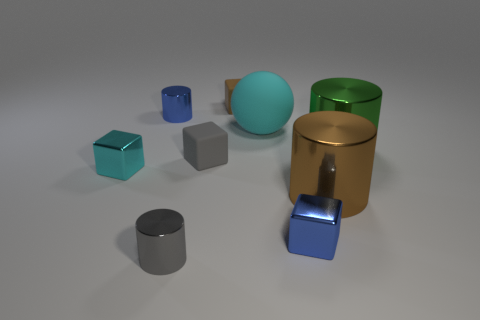Add 1 brown shiny cylinders. How many objects exist? 10 Subtract 2 cylinders. How many cylinders are left? 2 Subtract all gray cubes. How many cubes are left? 3 Subtract all big green objects. Subtract all tiny metallic things. How many objects are left? 4 Add 2 large brown objects. How many large brown objects are left? 3 Add 7 green shiny balls. How many green shiny balls exist? 7 Subtract 1 gray cylinders. How many objects are left? 8 Subtract all balls. How many objects are left? 8 Subtract all gray cylinders. Subtract all gray blocks. How many cylinders are left? 3 